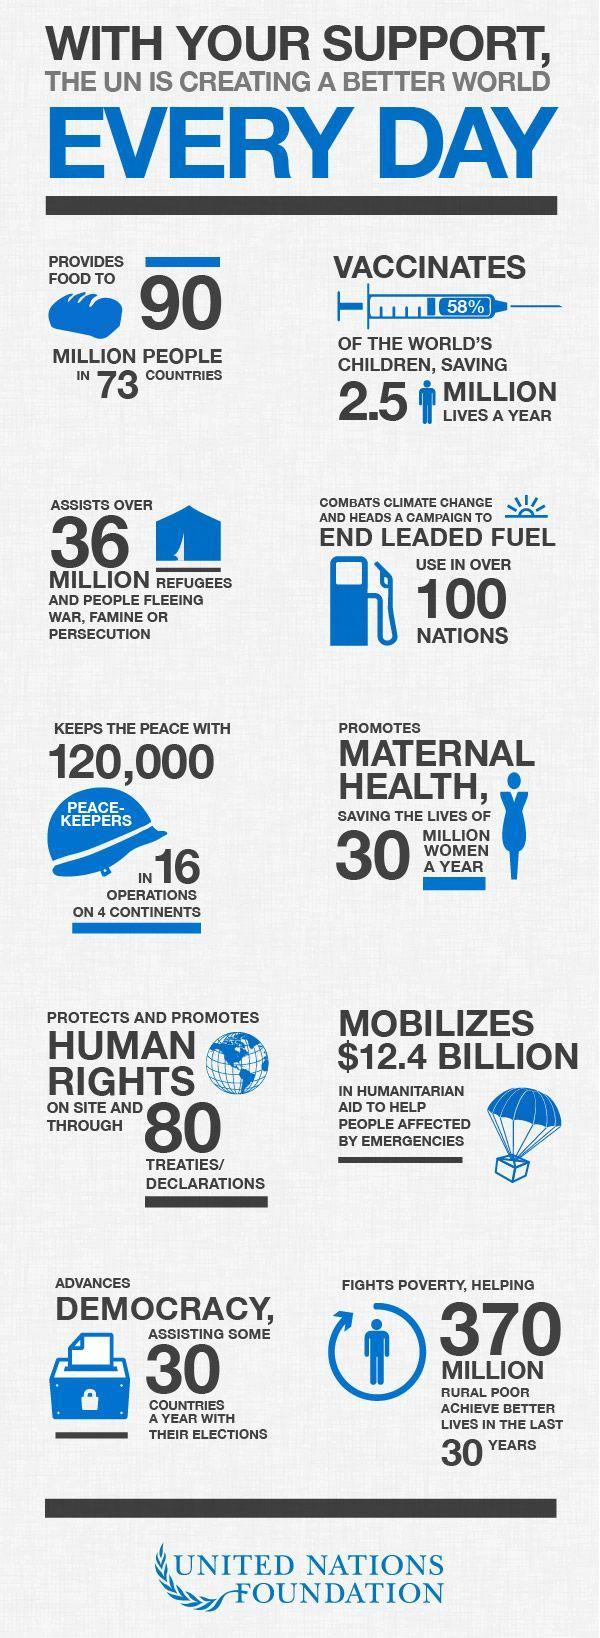what is written on the hat
Answer the question with a short phrase. peace-keepers what is written inside the syringe 58% 